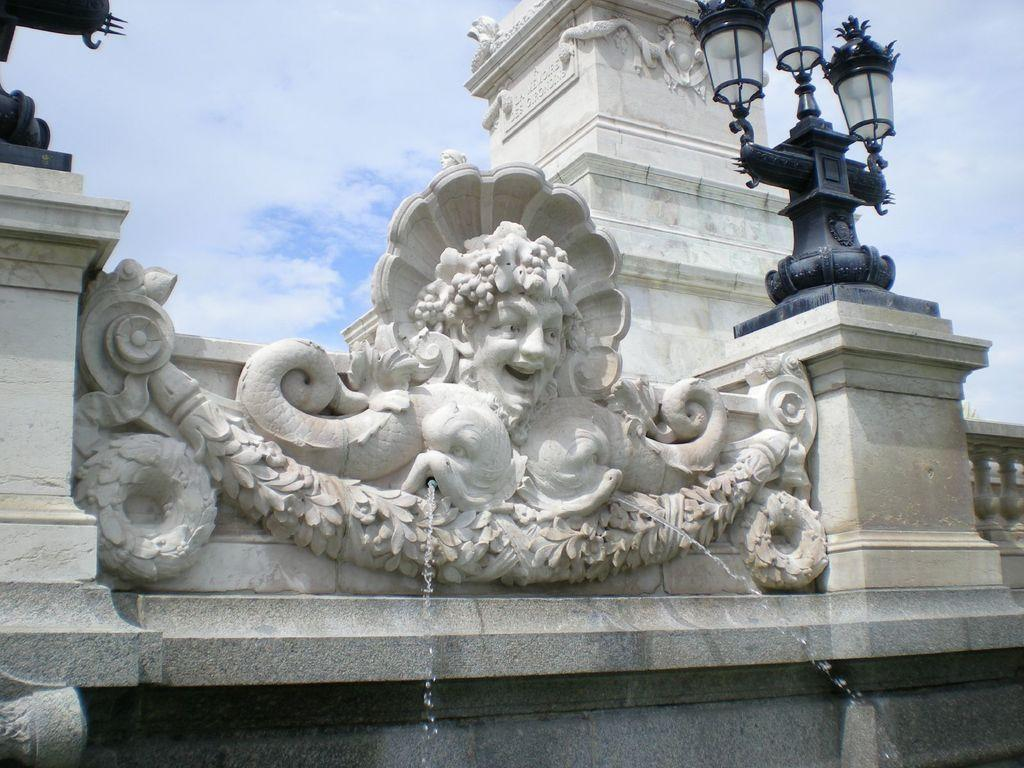What is the main subject of the image? There is a sculpture on a fountain in the image. What can be seen in the background of the image? There is a pillar in the background of the image. What is illuminating the scene in the image? There are lights visible in the image. What is visible above the scene in the image? The sky is visible in the image. What type of coal is being used to heat the oven in the image? There is no oven or coal present in the image; it features a sculpture on a fountain with a pillar in the background, lights, and the sky visible. 